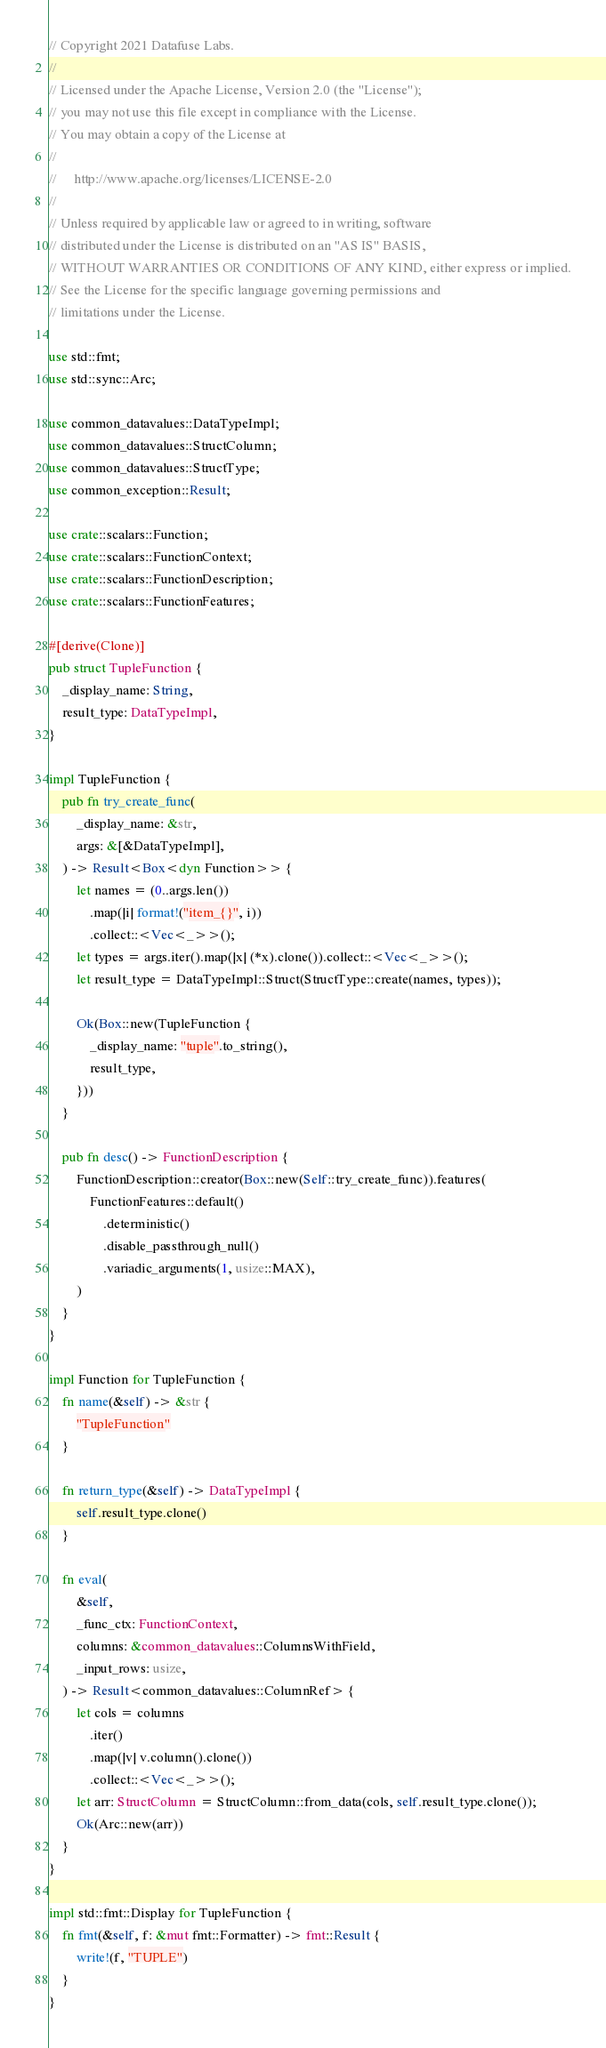<code> <loc_0><loc_0><loc_500><loc_500><_Rust_>// Copyright 2021 Datafuse Labs.
//
// Licensed under the Apache License, Version 2.0 (the "License");
// you may not use this file except in compliance with the License.
// You may obtain a copy of the License at
//
//     http://www.apache.org/licenses/LICENSE-2.0
//
// Unless required by applicable law or agreed to in writing, software
// distributed under the License is distributed on an "AS IS" BASIS,
// WITHOUT WARRANTIES OR CONDITIONS OF ANY KIND, either express or implied.
// See the License for the specific language governing permissions and
// limitations under the License.

use std::fmt;
use std::sync::Arc;

use common_datavalues::DataTypeImpl;
use common_datavalues::StructColumn;
use common_datavalues::StructType;
use common_exception::Result;

use crate::scalars::Function;
use crate::scalars::FunctionContext;
use crate::scalars::FunctionDescription;
use crate::scalars::FunctionFeatures;

#[derive(Clone)]
pub struct TupleFunction {
    _display_name: String,
    result_type: DataTypeImpl,
}

impl TupleFunction {
    pub fn try_create_func(
        _display_name: &str,
        args: &[&DataTypeImpl],
    ) -> Result<Box<dyn Function>> {
        let names = (0..args.len())
            .map(|i| format!("item_{}", i))
            .collect::<Vec<_>>();
        let types = args.iter().map(|x| (*x).clone()).collect::<Vec<_>>();
        let result_type = DataTypeImpl::Struct(StructType::create(names, types));

        Ok(Box::new(TupleFunction {
            _display_name: "tuple".to_string(),
            result_type,
        }))
    }

    pub fn desc() -> FunctionDescription {
        FunctionDescription::creator(Box::new(Self::try_create_func)).features(
            FunctionFeatures::default()
                .deterministic()
                .disable_passthrough_null()
                .variadic_arguments(1, usize::MAX),
        )
    }
}

impl Function for TupleFunction {
    fn name(&self) -> &str {
        "TupleFunction"
    }

    fn return_type(&self) -> DataTypeImpl {
        self.result_type.clone()
    }

    fn eval(
        &self,
        _func_ctx: FunctionContext,
        columns: &common_datavalues::ColumnsWithField,
        _input_rows: usize,
    ) -> Result<common_datavalues::ColumnRef> {
        let cols = columns
            .iter()
            .map(|v| v.column().clone())
            .collect::<Vec<_>>();
        let arr: StructColumn = StructColumn::from_data(cols, self.result_type.clone());
        Ok(Arc::new(arr))
    }
}

impl std::fmt::Display for TupleFunction {
    fn fmt(&self, f: &mut fmt::Formatter) -> fmt::Result {
        write!(f, "TUPLE")
    }
}
</code> 